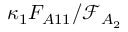Convert formula to latex. <formula><loc_0><loc_0><loc_500><loc_500>\kappa _ { 1 } F _ { A 1 1 } / \mathcal { F } _ { A _ { 2 } }</formula> 